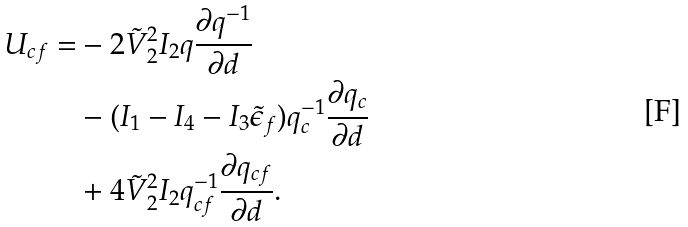Convert formula to latex. <formula><loc_0><loc_0><loc_500><loc_500>U _ { c f } = & - 2 \tilde { V } ^ { 2 } _ { 2 } I _ { 2 } q \frac { \partial q ^ { - 1 } } { \partial d } \\ & - ( I _ { 1 } - I _ { 4 } - I _ { 3 } \tilde { \epsilon } _ { f } ) q ^ { - 1 } _ { c } \frac { \partial q _ { c } } { \partial d } \\ & + 4 \tilde { V } ^ { 2 } _ { 2 } I _ { 2 } q ^ { - 1 } _ { c f } \frac { \partial q _ { c f } } { \partial d } .</formula> 